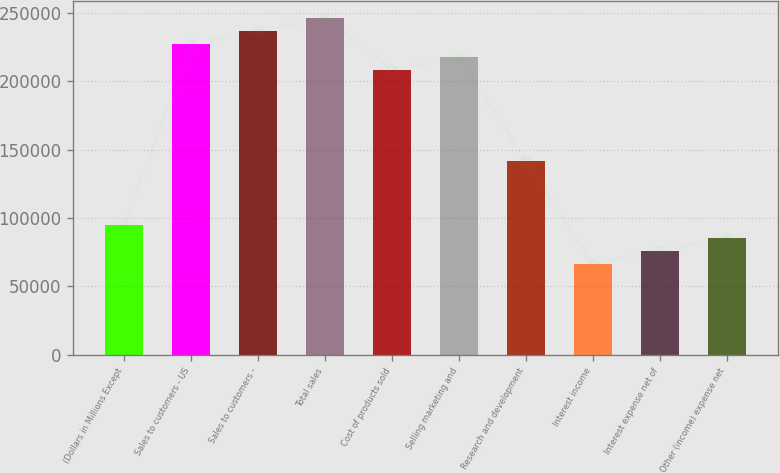Convert chart to OTSL. <chart><loc_0><loc_0><loc_500><loc_500><bar_chart><fcel>(Dollars in Millions Except<fcel>Sales to customers - US<fcel>Sales to customers -<fcel>Total sales<fcel>Cost of products sold<fcel>Selling marketing and<fcel>Research and development<fcel>Interest income<fcel>Interest expense net of<fcel>Other (income) expense net<nl><fcel>94682<fcel>227234<fcel>236702<fcel>246170<fcel>208298<fcel>217766<fcel>142022<fcel>66278<fcel>75746<fcel>85214<nl></chart> 